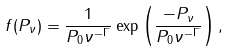<formula> <loc_0><loc_0><loc_500><loc_500>f ( P _ { \nu } ) = \frac { 1 } { P _ { 0 } \nu ^ { - \Gamma } } \exp \left ( \frac { - P _ { \nu } } { P _ { 0 } \nu ^ { - \Gamma } } \right ) ,</formula> 